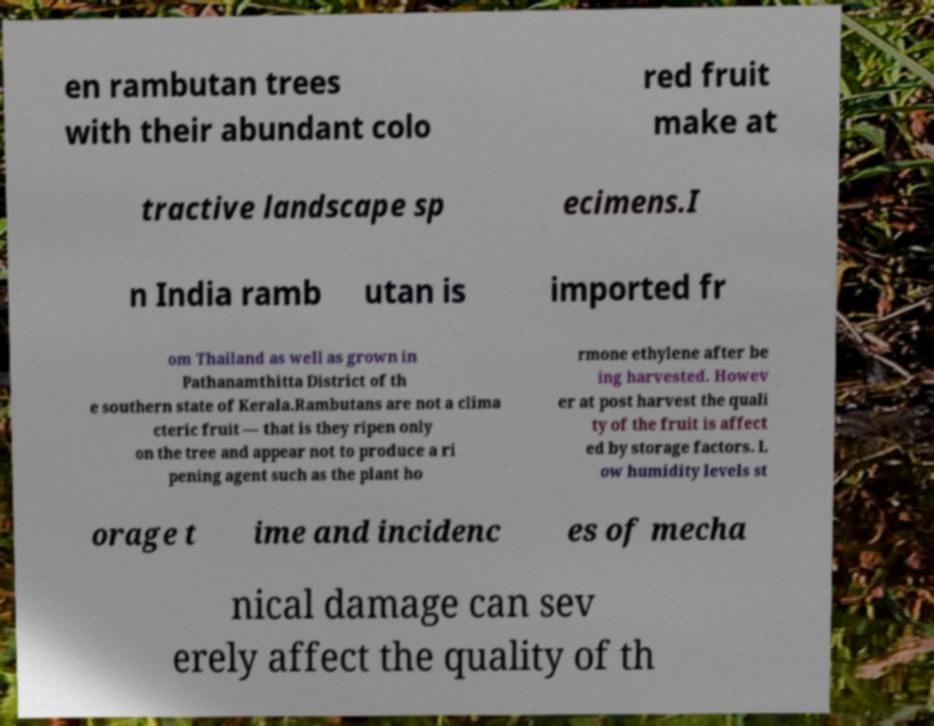Could you assist in decoding the text presented in this image and type it out clearly? en rambutan trees with their abundant colo red fruit make at tractive landscape sp ecimens.I n India ramb utan is imported fr om Thailand as well as grown in Pathanamthitta District of th e southern state of Kerala.Rambutans are not a clima cteric fruit — that is they ripen only on the tree and appear not to produce a ri pening agent such as the plant ho rmone ethylene after be ing harvested. Howev er at post harvest the quali ty of the fruit is affect ed by storage factors. L ow humidity levels st orage t ime and incidenc es of mecha nical damage can sev erely affect the quality of th 